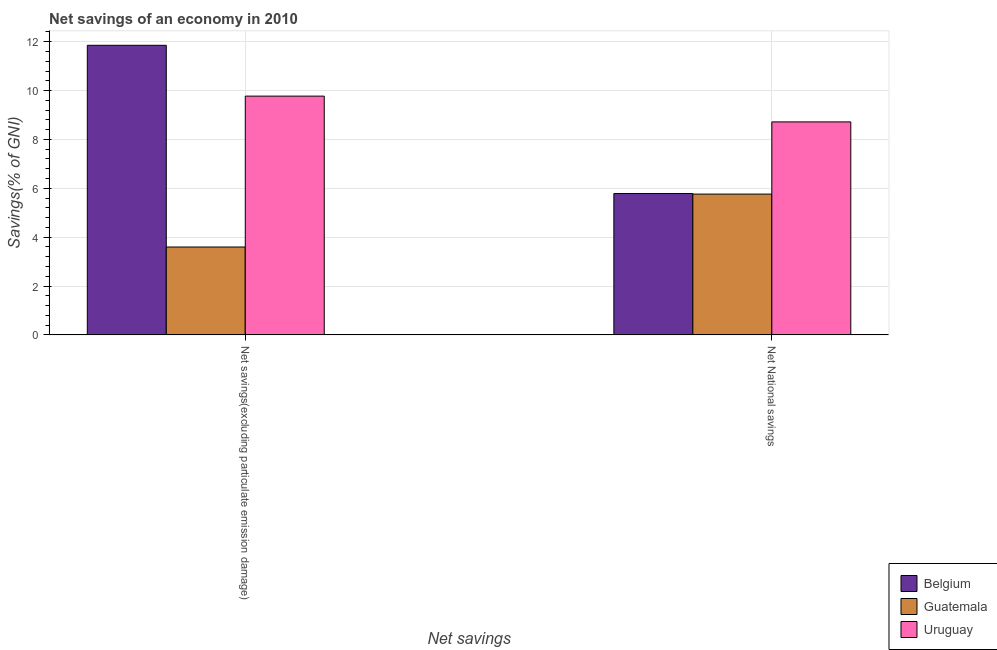Are the number of bars per tick equal to the number of legend labels?
Provide a short and direct response. Yes. How many bars are there on the 1st tick from the left?
Make the answer very short. 3. What is the label of the 2nd group of bars from the left?
Provide a succinct answer. Net National savings. What is the net savings(excluding particulate emission damage) in Uruguay?
Provide a succinct answer. 9.77. Across all countries, what is the maximum net national savings?
Provide a short and direct response. 8.72. Across all countries, what is the minimum net national savings?
Offer a very short reply. 5.76. In which country was the net savings(excluding particulate emission damage) maximum?
Offer a terse response. Belgium. In which country was the net national savings minimum?
Keep it short and to the point. Guatemala. What is the total net national savings in the graph?
Your answer should be very brief. 20.27. What is the difference between the net savings(excluding particulate emission damage) in Uruguay and that in Guatemala?
Make the answer very short. 6.18. What is the difference between the net savings(excluding particulate emission damage) in Guatemala and the net national savings in Uruguay?
Ensure brevity in your answer.  -5.12. What is the average net national savings per country?
Give a very brief answer. 6.76. What is the difference between the net savings(excluding particulate emission damage) and net national savings in Uruguay?
Keep it short and to the point. 1.06. What is the ratio of the net national savings in Guatemala to that in Uruguay?
Ensure brevity in your answer.  0.66. Is the net national savings in Belgium less than that in Uruguay?
Provide a succinct answer. Yes. In how many countries, is the net savings(excluding particulate emission damage) greater than the average net savings(excluding particulate emission damage) taken over all countries?
Your response must be concise. 2. What does the 3rd bar from the left in Net savings(excluding particulate emission damage) represents?
Ensure brevity in your answer.  Uruguay. What does the 2nd bar from the right in Net savings(excluding particulate emission damage) represents?
Keep it short and to the point. Guatemala. How many bars are there?
Make the answer very short. 6. Are all the bars in the graph horizontal?
Give a very brief answer. No. How many countries are there in the graph?
Keep it short and to the point. 3. Does the graph contain grids?
Make the answer very short. Yes. Where does the legend appear in the graph?
Your answer should be compact. Bottom right. What is the title of the graph?
Provide a short and direct response. Net savings of an economy in 2010. Does "Philippines" appear as one of the legend labels in the graph?
Your answer should be very brief. No. What is the label or title of the X-axis?
Your response must be concise. Net savings. What is the label or title of the Y-axis?
Offer a very short reply. Savings(% of GNI). What is the Savings(% of GNI) in Belgium in Net savings(excluding particulate emission damage)?
Provide a succinct answer. 11.85. What is the Savings(% of GNI) of Guatemala in Net savings(excluding particulate emission damage)?
Offer a very short reply. 3.6. What is the Savings(% of GNI) of Uruguay in Net savings(excluding particulate emission damage)?
Give a very brief answer. 9.77. What is the Savings(% of GNI) of Belgium in Net National savings?
Provide a succinct answer. 5.79. What is the Savings(% of GNI) in Guatemala in Net National savings?
Make the answer very short. 5.76. What is the Savings(% of GNI) of Uruguay in Net National savings?
Give a very brief answer. 8.72. Across all Net savings, what is the maximum Savings(% of GNI) of Belgium?
Provide a succinct answer. 11.85. Across all Net savings, what is the maximum Savings(% of GNI) in Guatemala?
Give a very brief answer. 5.76. Across all Net savings, what is the maximum Savings(% of GNI) of Uruguay?
Keep it short and to the point. 9.77. Across all Net savings, what is the minimum Savings(% of GNI) in Belgium?
Your response must be concise. 5.79. Across all Net savings, what is the minimum Savings(% of GNI) of Guatemala?
Ensure brevity in your answer.  3.6. Across all Net savings, what is the minimum Savings(% of GNI) in Uruguay?
Give a very brief answer. 8.72. What is the total Savings(% of GNI) in Belgium in the graph?
Offer a terse response. 17.64. What is the total Savings(% of GNI) in Guatemala in the graph?
Ensure brevity in your answer.  9.36. What is the total Savings(% of GNI) in Uruguay in the graph?
Offer a terse response. 18.49. What is the difference between the Savings(% of GNI) of Belgium in Net savings(excluding particulate emission damage) and that in Net National savings?
Your answer should be very brief. 6.07. What is the difference between the Savings(% of GNI) in Guatemala in Net savings(excluding particulate emission damage) and that in Net National savings?
Offer a terse response. -2.17. What is the difference between the Savings(% of GNI) in Uruguay in Net savings(excluding particulate emission damage) and that in Net National savings?
Provide a short and direct response. 1.06. What is the difference between the Savings(% of GNI) of Belgium in Net savings(excluding particulate emission damage) and the Savings(% of GNI) of Guatemala in Net National savings?
Give a very brief answer. 6.09. What is the difference between the Savings(% of GNI) in Belgium in Net savings(excluding particulate emission damage) and the Savings(% of GNI) in Uruguay in Net National savings?
Offer a terse response. 3.14. What is the difference between the Savings(% of GNI) of Guatemala in Net savings(excluding particulate emission damage) and the Savings(% of GNI) of Uruguay in Net National savings?
Give a very brief answer. -5.12. What is the average Savings(% of GNI) of Belgium per Net savings?
Give a very brief answer. 8.82. What is the average Savings(% of GNI) of Guatemala per Net savings?
Ensure brevity in your answer.  4.68. What is the average Savings(% of GNI) in Uruguay per Net savings?
Offer a very short reply. 9.25. What is the difference between the Savings(% of GNI) of Belgium and Savings(% of GNI) of Guatemala in Net savings(excluding particulate emission damage)?
Provide a succinct answer. 8.26. What is the difference between the Savings(% of GNI) in Belgium and Savings(% of GNI) in Uruguay in Net savings(excluding particulate emission damage)?
Keep it short and to the point. 2.08. What is the difference between the Savings(% of GNI) in Guatemala and Savings(% of GNI) in Uruguay in Net savings(excluding particulate emission damage)?
Provide a succinct answer. -6.18. What is the difference between the Savings(% of GNI) of Belgium and Savings(% of GNI) of Guatemala in Net National savings?
Provide a succinct answer. 0.02. What is the difference between the Savings(% of GNI) of Belgium and Savings(% of GNI) of Uruguay in Net National savings?
Give a very brief answer. -2.93. What is the difference between the Savings(% of GNI) of Guatemala and Savings(% of GNI) of Uruguay in Net National savings?
Make the answer very short. -2.96. What is the ratio of the Savings(% of GNI) of Belgium in Net savings(excluding particulate emission damage) to that in Net National savings?
Keep it short and to the point. 2.05. What is the ratio of the Savings(% of GNI) of Guatemala in Net savings(excluding particulate emission damage) to that in Net National savings?
Provide a succinct answer. 0.62. What is the ratio of the Savings(% of GNI) in Uruguay in Net savings(excluding particulate emission damage) to that in Net National savings?
Provide a short and direct response. 1.12. What is the difference between the highest and the second highest Savings(% of GNI) of Belgium?
Ensure brevity in your answer.  6.07. What is the difference between the highest and the second highest Savings(% of GNI) in Guatemala?
Keep it short and to the point. 2.17. What is the difference between the highest and the second highest Savings(% of GNI) in Uruguay?
Your answer should be very brief. 1.06. What is the difference between the highest and the lowest Savings(% of GNI) of Belgium?
Make the answer very short. 6.07. What is the difference between the highest and the lowest Savings(% of GNI) in Guatemala?
Ensure brevity in your answer.  2.17. What is the difference between the highest and the lowest Savings(% of GNI) of Uruguay?
Keep it short and to the point. 1.06. 